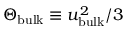<formula> <loc_0><loc_0><loc_500><loc_500>\Theta _ { b u l k } \equiv u _ { b u l k } ^ { 2 } / 3</formula> 